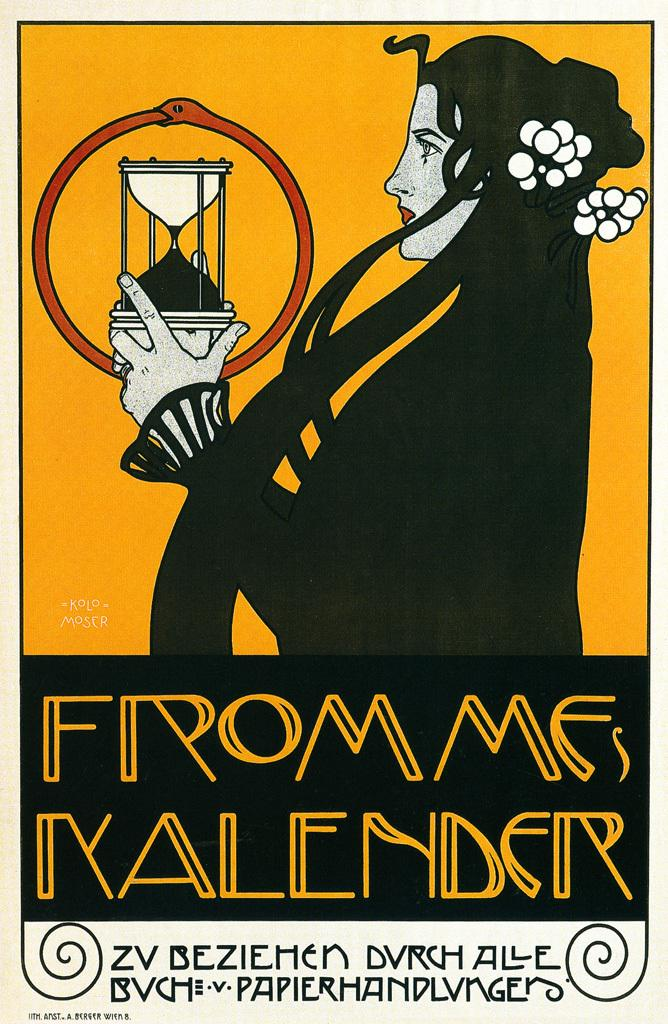<image>
Share a concise interpretation of the image provided. The cover from Frommes Kalender has a woman on it. 